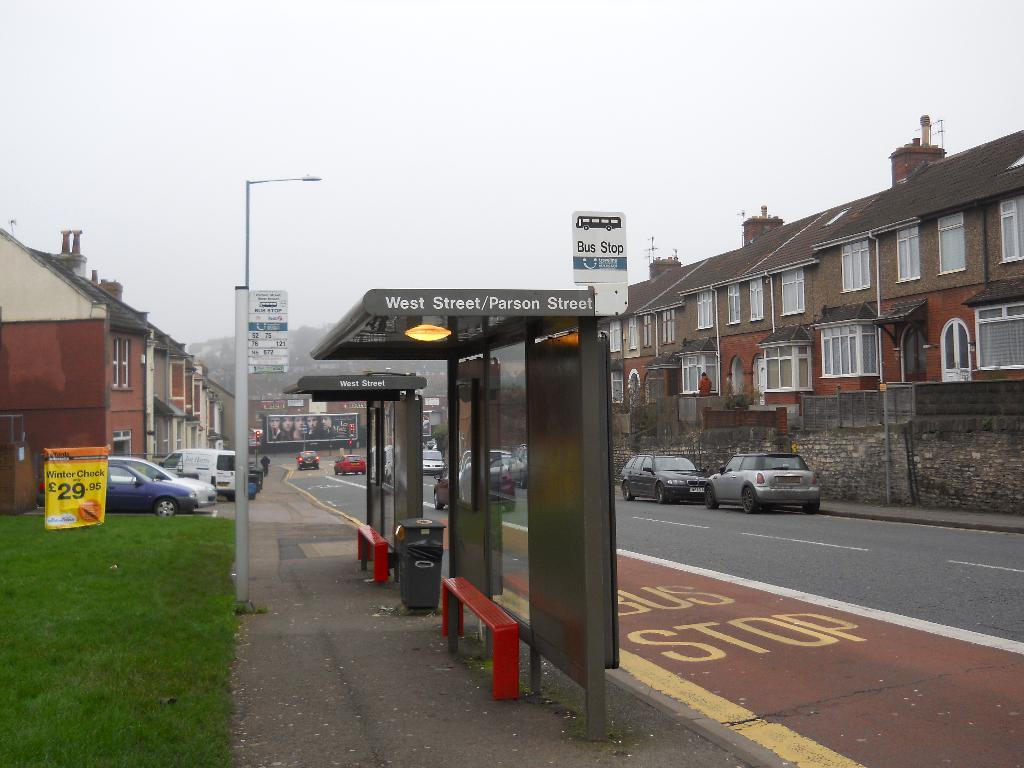<image>
Give a short and clear explanation of the subsequent image. The bus stop for West Street/Parson Street sits to the left of the city street. 